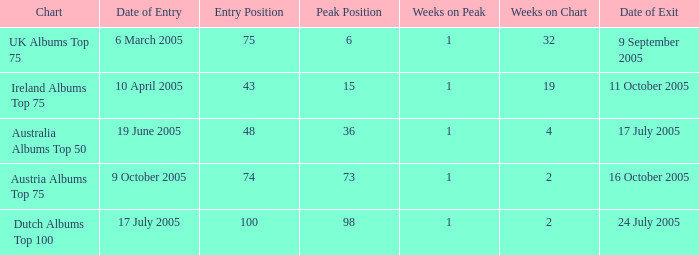What is the date of entry for the UK Albums Top 75 chart? 6 March 2005. Parse the full table. {'header': ['Chart', 'Date of Entry', 'Entry Position', 'Peak Position', 'Weeks on Peak', 'Weeks on Chart', 'Date of Exit'], 'rows': [['UK Albums Top 75', '6 March 2005', '75', '6', '1', '32', '9 September 2005'], ['Ireland Albums Top 75', '10 April 2005', '43', '15', '1', '19', '11 October 2005'], ['Australia Albums Top 50', '19 June 2005', '48', '36', '1', '4', '17 July 2005'], ['Austria Albums Top 75', '9 October 2005', '74', '73', '1', '2', '16 October 2005'], ['Dutch Albums Top 100', '17 July 2005', '100', '98', '1', '2', '24 July 2005']]} 